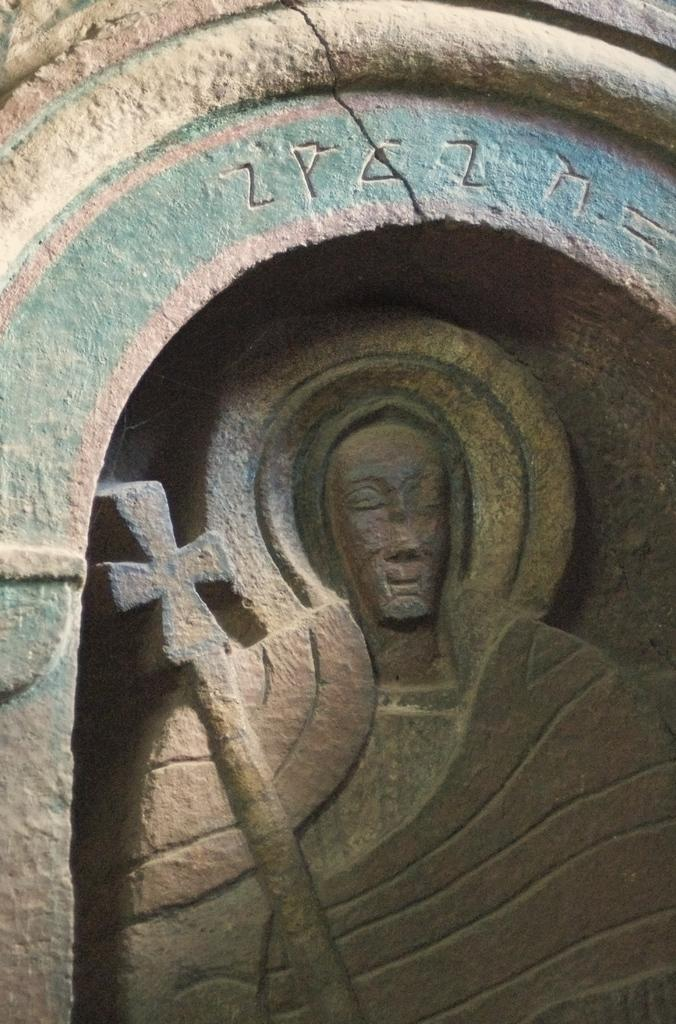What is the main subject of the image? There is a sculpture in the image. Can you describe any additional elements in the image? There is writing in the image. What type of calculator is being used by the brothers in the image? There is no calculator or brothers present in the image; it only features a sculpture and writing. 